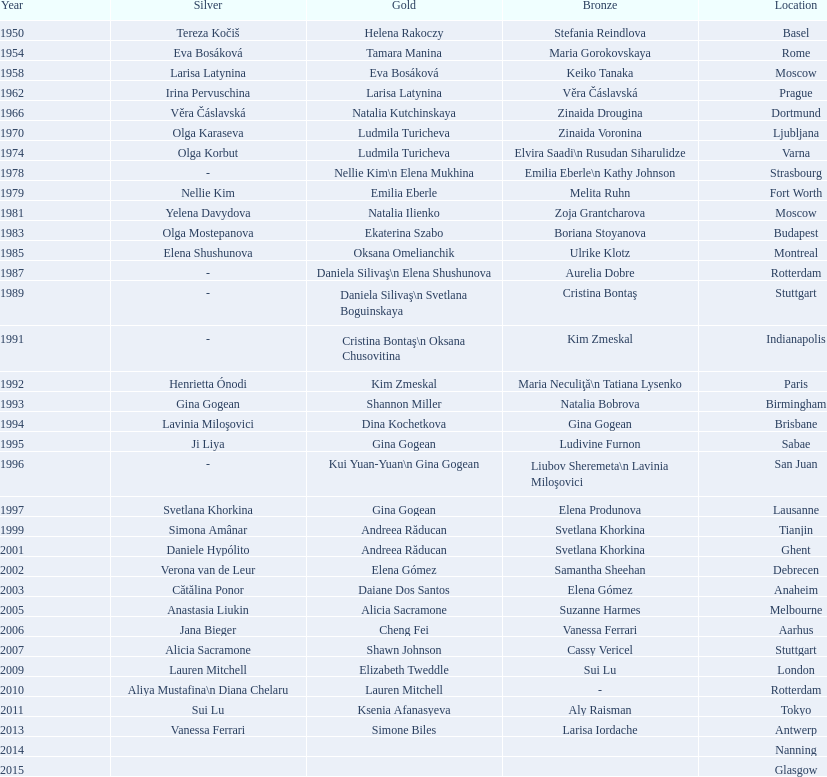How many consecutive floor exercise gold medals did romanian star andreea raducan win at the world championships? 2. 